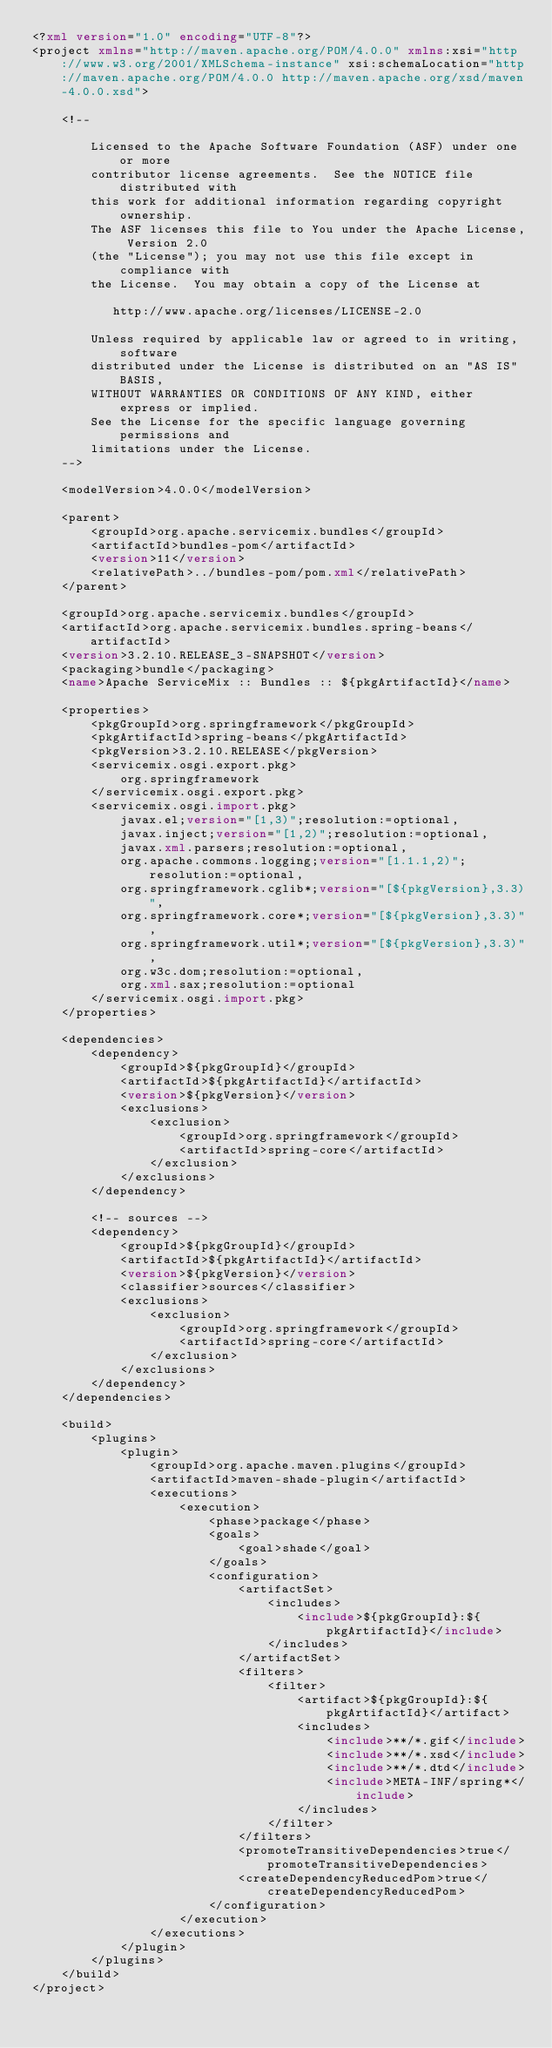<code> <loc_0><loc_0><loc_500><loc_500><_XML_><?xml version="1.0" encoding="UTF-8"?>
<project xmlns="http://maven.apache.org/POM/4.0.0" xmlns:xsi="http://www.w3.org/2001/XMLSchema-instance" xsi:schemaLocation="http://maven.apache.org/POM/4.0.0 http://maven.apache.org/xsd/maven-4.0.0.xsd">

    <!--

        Licensed to the Apache Software Foundation (ASF) under one or more
        contributor license agreements.  See the NOTICE file distributed with
        this work for additional information regarding copyright ownership.
        The ASF licenses this file to You under the Apache License, Version 2.0
        (the "License"); you may not use this file except in compliance with
        the License.  You may obtain a copy of the License at

           http://www.apache.org/licenses/LICENSE-2.0

        Unless required by applicable law or agreed to in writing, software
        distributed under the License is distributed on an "AS IS" BASIS,
        WITHOUT WARRANTIES OR CONDITIONS OF ANY KIND, either express or implied.
        See the License for the specific language governing permissions and
        limitations under the License.
    -->

    <modelVersion>4.0.0</modelVersion>

    <parent>
        <groupId>org.apache.servicemix.bundles</groupId>
        <artifactId>bundles-pom</artifactId>
        <version>11</version>
        <relativePath>../bundles-pom/pom.xml</relativePath>
    </parent>

    <groupId>org.apache.servicemix.bundles</groupId>
    <artifactId>org.apache.servicemix.bundles.spring-beans</artifactId>
    <version>3.2.10.RELEASE_3-SNAPSHOT</version>
    <packaging>bundle</packaging>
    <name>Apache ServiceMix :: Bundles :: ${pkgArtifactId}</name>

    <properties>
        <pkgGroupId>org.springframework</pkgGroupId>
        <pkgArtifactId>spring-beans</pkgArtifactId>
        <pkgVersion>3.2.10.RELEASE</pkgVersion>
        <servicemix.osgi.export.pkg>
            org.springframework
        </servicemix.osgi.export.pkg>
        <servicemix.osgi.import.pkg>
            javax.el;version="[1,3)";resolution:=optional,
            javax.inject;version="[1,2)";resolution:=optional,
            javax.xml.parsers;resolution:=optional,
            org.apache.commons.logging;version="[1.1.1,2)";resolution:=optional,
            org.springframework.cglib*;version="[${pkgVersion},3.3)",
            org.springframework.core*;version="[${pkgVersion},3.3)",
            org.springframework.util*;version="[${pkgVersion},3.3)",
            org.w3c.dom;resolution:=optional,
            org.xml.sax;resolution:=optional 
        </servicemix.osgi.import.pkg>
    </properties>

    <dependencies>
        <dependency>
            <groupId>${pkgGroupId}</groupId>
            <artifactId>${pkgArtifactId}</artifactId>
            <version>${pkgVersion}</version>
            <exclusions>
                <exclusion>
                    <groupId>org.springframework</groupId>
                    <artifactId>spring-core</artifactId>
                </exclusion>
            </exclusions>
        </dependency>

        <!-- sources -->
        <dependency>
            <groupId>${pkgGroupId}</groupId>
            <artifactId>${pkgArtifactId}</artifactId>
            <version>${pkgVersion}</version>
            <classifier>sources</classifier>
            <exclusions>
                <exclusion>
                    <groupId>org.springframework</groupId>
                    <artifactId>spring-core</artifactId>
                </exclusion>
            </exclusions>
        </dependency>
    </dependencies>

    <build>
        <plugins>
            <plugin>
                <groupId>org.apache.maven.plugins</groupId>
                <artifactId>maven-shade-plugin</artifactId>
                <executions>
                    <execution>
                        <phase>package</phase>
                        <goals>
                            <goal>shade</goal>
                        </goals>
                        <configuration>
                            <artifactSet>
                                <includes>
                                    <include>${pkgGroupId}:${pkgArtifactId}</include>
                                </includes>
                            </artifactSet>
                            <filters>
                                <filter>
                                    <artifact>${pkgGroupId}:${pkgArtifactId}</artifact>
                                    <includes>
                                        <include>**/*.gif</include>
                                        <include>**/*.xsd</include>
                                        <include>**/*.dtd</include>
                                        <include>META-INF/spring*</include>
                                    </includes>
                                </filter>
                            </filters>
                            <promoteTransitiveDependencies>true</promoteTransitiveDependencies>
                            <createDependencyReducedPom>true</createDependencyReducedPom>
                        </configuration>
                    </execution>
                </executions>
            </plugin>
        </plugins>
    </build>
</project>
</code> 